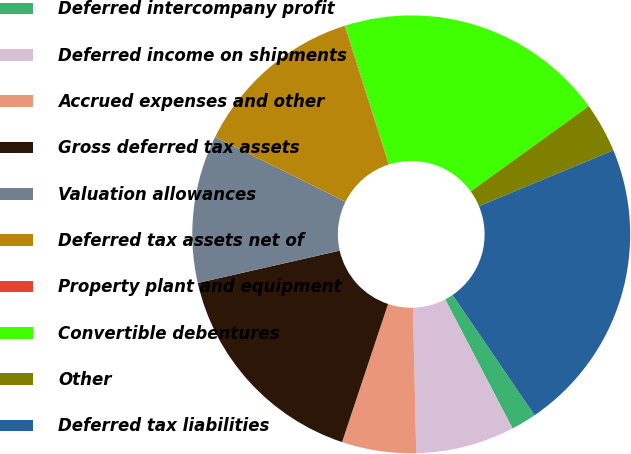Convert chart. <chart><loc_0><loc_0><loc_500><loc_500><pie_chart><fcel>Deferred intercompany profit<fcel>Deferred income on shipments<fcel>Accrued expenses and other<fcel>Gross deferred tax assets<fcel>Valuation allowances<fcel>Deferred tax assets net of<fcel>Property plant and equipment<fcel>Convertible debentures<fcel>Other<fcel>Deferred tax liabilities<nl><fcel>1.87%<fcel>7.29%<fcel>5.48%<fcel>16.32%<fcel>10.9%<fcel>12.71%<fcel>0.06%<fcel>19.94%<fcel>3.68%<fcel>21.74%<nl></chart> 